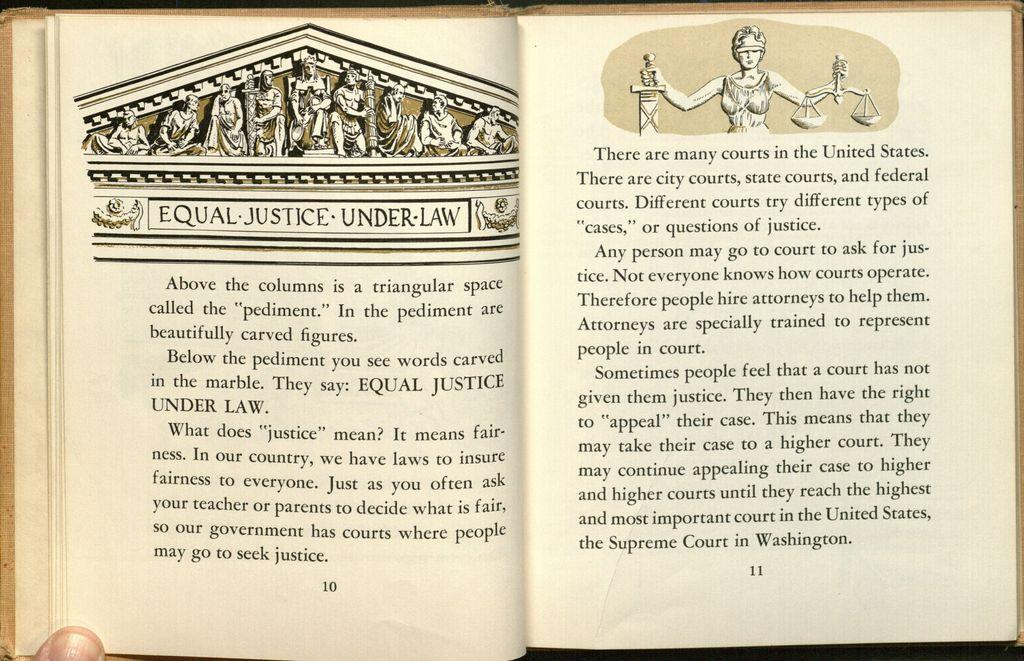What is the main object in the image? There is a book opened in the image. Can you describe the position of the book? A part of a person's finger is visible under the book. What subject matter is the book about? The book contains information about equal, justice, and law. Can you hear the group of people laughing in the image? There is no group of people or any indication of laughter in the image; it only features an opened book and a finger. 